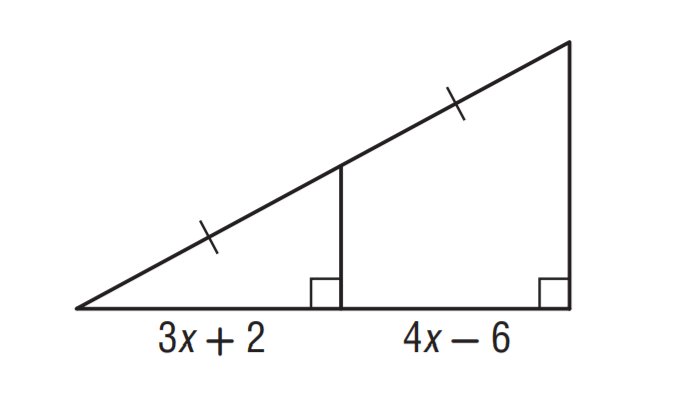Question: Find x.
Choices:
A. 4
B. 6
C. 8
D. 10
Answer with the letter. Answer: C 